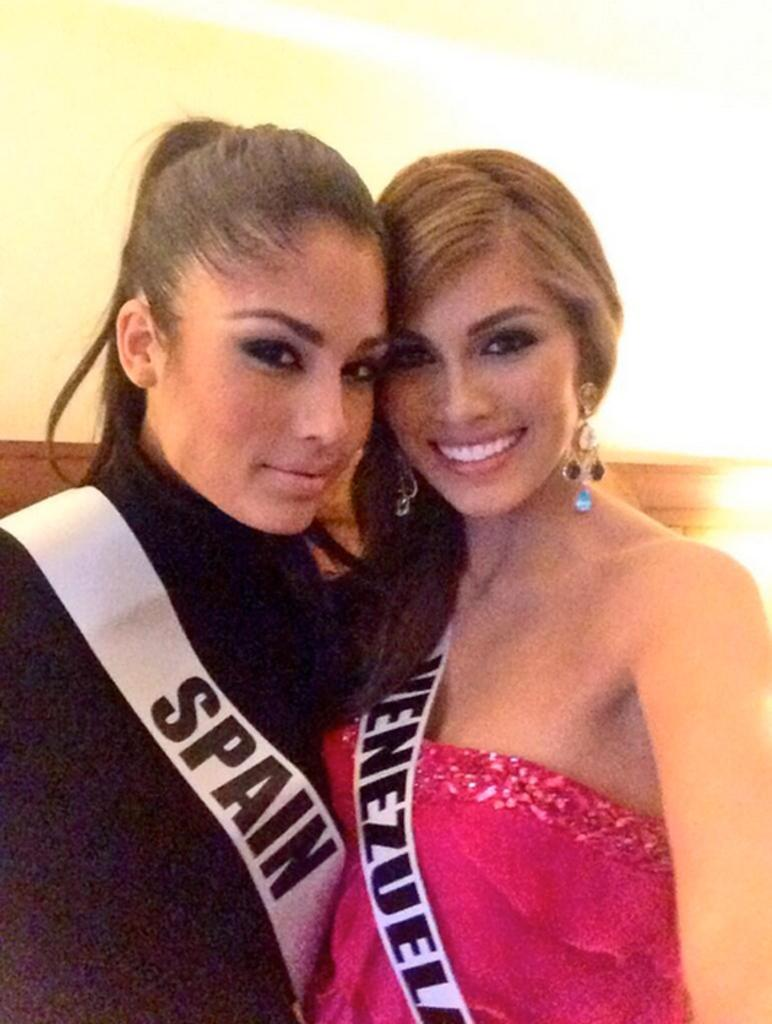<image>
Give a short and clear explanation of the subsequent image. The two beauty pageant contestants are from Spain and Venezuela. 